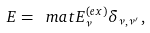<formula> <loc_0><loc_0><loc_500><loc_500>E = \ m a t { E ^ { ( e x ) } _ { \nu } \delta _ { \nu , \nu ^ { \prime } } } \, ,</formula> 